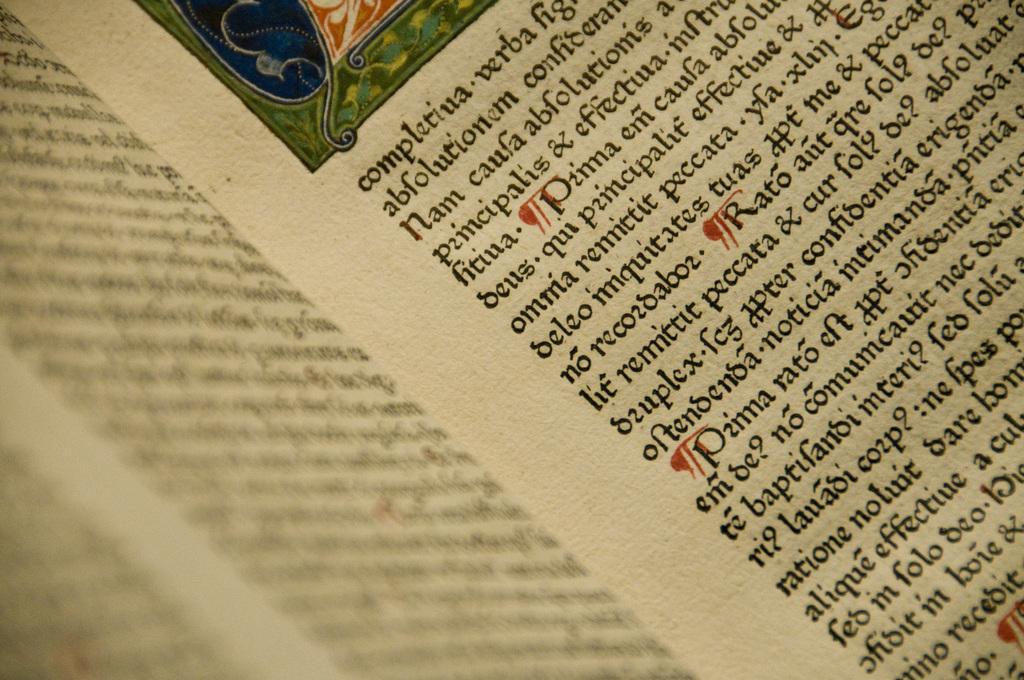Please provide a concise description of this image. In this image we can see a page of a book. 